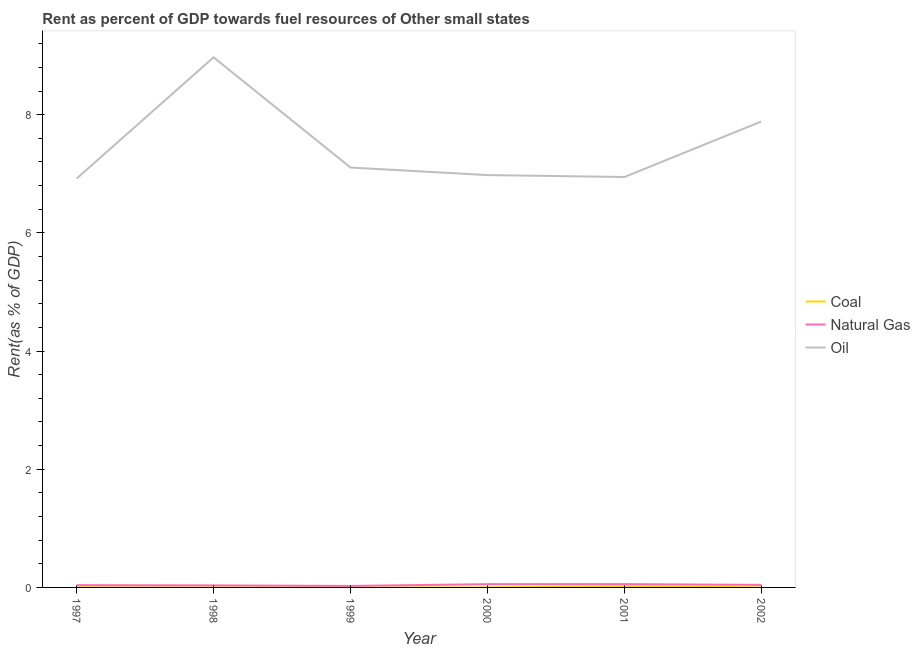How many different coloured lines are there?
Give a very brief answer. 3. Does the line corresponding to rent towards natural gas intersect with the line corresponding to rent towards coal?
Your answer should be compact. No. What is the rent towards oil in 2000?
Your answer should be very brief. 6.98. Across all years, what is the maximum rent towards coal?
Give a very brief answer. 0.02. Across all years, what is the minimum rent towards oil?
Your response must be concise. 6.92. In which year was the rent towards coal maximum?
Give a very brief answer. 2001. In which year was the rent towards natural gas minimum?
Offer a terse response. 1999. What is the total rent towards natural gas in the graph?
Keep it short and to the point. 0.25. What is the difference between the rent towards natural gas in 2000 and that in 2002?
Provide a succinct answer. 0.01. What is the difference between the rent towards natural gas in 1997 and the rent towards coal in 1999?
Ensure brevity in your answer.  0.04. What is the average rent towards oil per year?
Provide a succinct answer. 7.47. In the year 2000, what is the difference between the rent towards coal and rent towards natural gas?
Provide a short and direct response. -0.05. In how many years, is the rent towards oil greater than 3.6 %?
Provide a succinct answer. 6. What is the ratio of the rent towards natural gas in 1997 to that in 2000?
Your response must be concise. 0.7. Is the rent towards natural gas in 1998 less than that in 1999?
Ensure brevity in your answer.  No. What is the difference between the highest and the second highest rent towards natural gas?
Your response must be concise. 0. What is the difference between the highest and the lowest rent towards natural gas?
Your answer should be very brief. 0.03. In how many years, is the rent towards oil greater than the average rent towards oil taken over all years?
Make the answer very short. 2. Is it the case that in every year, the sum of the rent towards coal and rent towards natural gas is greater than the rent towards oil?
Make the answer very short. No. Does the rent towards oil monotonically increase over the years?
Provide a short and direct response. No. Is the rent towards coal strictly greater than the rent towards natural gas over the years?
Ensure brevity in your answer.  No. How many years are there in the graph?
Make the answer very short. 6. Are the values on the major ticks of Y-axis written in scientific E-notation?
Make the answer very short. No. Does the graph contain any zero values?
Make the answer very short. No. Where does the legend appear in the graph?
Your answer should be very brief. Center right. How many legend labels are there?
Give a very brief answer. 3. How are the legend labels stacked?
Give a very brief answer. Vertical. What is the title of the graph?
Your response must be concise. Rent as percent of GDP towards fuel resources of Other small states. What is the label or title of the Y-axis?
Ensure brevity in your answer.  Rent(as % of GDP). What is the Rent(as % of GDP) in Coal in 1997?
Make the answer very short. 0. What is the Rent(as % of GDP) of Natural Gas in 1997?
Make the answer very short. 0.04. What is the Rent(as % of GDP) of Oil in 1997?
Keep it short and to the point. 6.92. What is the Rent(as % of GDP) in Coal in 1998?
Give a very brief answer. 0. What is the Rent(as % of GDP) in Natural Gas in 1998?
Your answer should be compact. 0.03. What is the Rent(as % of GDP) of Oil in 1998?
Keep it short and to the point. 8.97. What is the Rent(as % of GDP) in Coal in 1999?
Provide a short and direct response. 8.31774864799922e-5. What is the Rent(as % of GDP) of Natural Gas in 1999?
Offer a very short reply. 0.03. What is the Rent(as % of GDP) of Oil in 1999?
Your response must be concise. 7.11. What is the Rent(as % of GDP) in Coal in 2000?
Make the answer very short. 0. What is the Rent(as % of GDP) in Natural Gas in 2000?
Give a very brief answer. 0.06. What is the Rent(as % of GDP) of Oil in 2000?
Give a very brief answer. 6.98. What is the Rent(as % of GDP) in Coal in 2001?
Provide a succinct answer. 0.02. What is the Rent(as % of GDP) of Natural Gas in 2001?
Ensure brevity in your answer.  0.06. What is the Rent(as % of GDP) in Oil in 2001?
Make the answer very short. 6.95. What is the Rent(as % of GDP) in Coal in 2002?
Keep it short and to the point. 0. What is the Rent(as % of GDP) of Natural Gas in 2002?
Make the answer very short. 0.04. What is the Rent(as % of GDP) in Oil in 2002?
Make the answer very short. 7.89. Across all years, what is the maximum Rent(as % of GDP) in Coal?
Offer a terse response. 0.02. Across all years, what is the maximum Rent(as % of GDP) in Natural Gas?
Offer a very short reply. 0.06. Across all years, what is the maximum Rent(as % of GDP) in Oil?
Your answer should be very brief. 8.97. Across all years, what is the minimum Rent(as % of GDP) of Coal?
Your answer should be very brief. 8.31774864799922e-5. Across all years, what is the minimum Rent(as % of GDP) of Natural Gas?
Keep it short and to the point. 0.03. Across all years, what is the minimum Rent(as % of GDP) of Oil?
Keep it short and to the point. 6.92. What is the total Rent(as % of GDP) in Coal in the graph?
Give a very brief answer. 0.02. What is the total Rent(as % of GDP) of Natural Gas in the graph?
Offer a terse response. 0.25. What is the total Rent(as % of GDP) in Oil in the graph?
Make the answer very short. 44.8. What is the difference between the Rent(as % of GDP) in Coal in 1997 and that in 1998?
Your response must be concise. 0. What is the difference between the Rent(as % of GDP) of Natural Gas in 1997 and that in 1998?
Ensure brevity in your answer.  0. What is the difference between the Rent(as % of GDP) in Oil in 1997 and that in 1998?
Give a very brief answer. -2.05. What is the difference between the Rent(as % of GDP) in Coal in 1997 and that in 1999?
Offer a very short reply. 0. What is the difference between the Rent(as % of GDP) in Natural Gas in 1997 and that in 1999?
Ensure brevity in your answer.  0.01. What is the difference between the Rent(as % of GDP) of Oil in 1997 and that in 1999?
Keep it short and to the point. -0.19. What is the difference between the Rent(as % of GDP) of Coal in 1997 and that in 2000?
Offer a very short reply. 0. What is the difference between the Rent(as % of GDP) in Natural Gas in 1997 and that in 2000?
Keep it short and to the point. -0.02. What is the difference between the Rent(as % of GDP) of Oil in 1997 and that in 2000?
Your answer should be compact. -0.06. What is the difference between the Rent(as % of GDP) of Coal in 1997 and that in 2001?
Offer a terse response. -0.02. What is the difference between the Rent(as % of GDP) of Natural Gas in 1997 and that in 2001?
Your response must be concise. -0.02. What is the difference between the Rent(as % of GDP) of Oil in 1997 and that in 2001?
Your response must be concise. -0.03. What is the difference between the Rent(as % of GDP) in Coal in 1997 and that in 2002?
Your response must be concise. 0. What is the difference between the Rent(as % of GDP) in Natural Gas in 1997 and that in 2002?
Provide a succinct answer. -0. What is the difference between the Rent(as % of GDP) of Oil in 1997 and that in 2002?
Ensure brevity in your answer.  -0.97. What is the difference between the Rent(as % of GDP) in Coal in 1998 and that in 1999?
Your response must be concise. 0. What is the difference between the Rent(as % of GDP) in Natural Gas in 1998 and that in 1999?
Your response must be concise. 0.01. What is the difference between the Rent(as % of GDP) of Oil in 1998 and that in 1999?
Ensure brevity in your answer.  1.87. What is the difference between the Rent(as % of GDP) of Coal in 1998 and that in 2000?
Provide a succinct answer. 0. What is the difference between the Rent(as % of GDP) of Natural Gas in 1998 and that in 2000?
Your answer should be very brief. -0.02. What is the difference between the Rent(as % of GDP) in Oil in 1998 and that in 2000?
Offer a very short reply. 1.99. What is the difference between the Rent(as % of GDP) of Coal in 1998 and that in 2001?
Your answer should be compact. -0.02. What is the difference between the Rent(as % of GDP) in Natural Gas in 1998 and that in 2001?
Keep it short and to the point. -0.02. What is the difference between the Rent(as % of GDP) of Oil in 1998 and that in 2001?
Give a very brief answer. 2.03. What is the difference between the Rent(as % of GDP) in Coal in 1998 and that in 2002?
Keep it short and to the point. -0. What is the difference between the Rent(as % of GDP) in Natural Gas in 1998 and that in 2002?
Give a very brief answer. -0.01. What is the difference between the Rent(as % of GDP) in Oil in 1998 and that in 2002?
Provide a short and direct response. 1.09. What is the difference between the Rent(as % of GDP) in Coal in 1999 and that in 2000?
Offer a terse response. -0. What is the difference between the Rent(as % of GDP) of Natural Gas in 1999 and that in 2000?
Offer a very short reply. -0.03. What is the difference between the Rent(as % of GDP) of Oil in 1999 and that in 2000?
Make the answer very short. 0.13. What is the difference between the Rent(as % of GDP) in Coal in 1999 and that in 2001?
Offer a very short reply. -0.02. What is the difference between the Rent(as % of GDP) of Natural Gas in 1999 and that in 2001?
Your answer should be very brief. -0.03. What is the difference between the Rent(as % of GDP) of Oil in 1999 and that in 2001?
Keep it short and to the point. 0.16. What is the difference between the Rent(as % of GDP) of Coal in 1999 and that in 2002?
Offer a terse response. -0. What is the difference between the Rent(as % of GDP) of Natural Gas in 1999 and that in 2002?
Your answer should be compact. -0.02. What is the difference between the Rent(as % of GDP) of Oil in 1999 and that in 2002?
Offer a terse response. -0.78. What is the difference between the Rent(as % of GDP) of Coal in 2000 and that in 2001?
Keep it short and to the point. -0.02. What is the difference between the Rent(as % of GDP) in Natural Gas in 2000 and that in 2001?
Your answer should be very brief. -0. What is the difference between the Rent(as % of GDP) of Oil in 2000 and that in 2001?
Offer a terse response. 0.03. What is the difference between the Rent(as % of GDP) of Coal in 2000 and that in 2002?
Make the answer very short. -0. What is the difference between the Rent(as % of GDP) of Natural Gas in 2000 and that in 2002?
Keep it short and to the point. 0.01. What is the difference between the Rent(as % of GDP) of Oil in 2000 and that in 2002?
Your answer should be very brief. -0.91. What is the difference between the Rent(as % of GDP) in Coal in 2001 and that in 2002?
Make the answer very short. 0.02. What is the difference between the Rent(as % of GDP) of Natural Gas in 2001 and that in 2002?
Provide a short and direct response. 0.01. What is the difference between the Rent(as % of GDP) of Oil in 2001 and that in 2002?
Make the answer very short. -0.94. What is the difference between the Rent(as % of GDP) of Coal in 1997 and the Rent(as % of GDP) of Natural Gas in 1998?
Offer a very short reply. -0.03. What is the difference between the Rent(as % of GDP) in Coal in 1997 and the Rent(as % of GDP) in Oil in 1998?
Your answer should be compact. -8.97. What is the difference between the Rent(as % of GDP) in Natural Gas in 1997 and the Rent(as % of GDP) in Oil in 1998?
Give a very brief answer. -8.93. What is the difference between the Rent(as % of GDP) of Coal in 1997 and the Rent(as % of GDP) of Natural Gas in 1999?
Give a very brief answer. -0.02. What is the difference between the Rent(as % of GDP) in Coal in 1997 and the Rent(as % of GDP) in Oil in 1999?
Your answer should be very brief. -7.1. What is the difference between the Rent(as % of GDP) in Natural Gas in 1997 and the Rent(as % of GDP) in Oil in 1999?
Provide a succinct answer. -7.07. What is the difference between the Rent(as % of GDP) in Coal in 1997 and the Rent(as % of GDP) in Natural Gas in 2000?
Your answer should be compact. -0.05. What is the difference between the Rent(as % of GDP) of Coal in 1997 and the Rent(as % of GDP) of Oil in 2000?
Offer a terse response. -6.98. What is the difference between the Rent(as % of GDP) of Natural Gas in 1997 and the Rent(as % of GDP) of Oil in 2000?
Keep it short and to the point. -6.94. What is the difference between the Rent(as % of GDP) of Coal in 1997 and the Rent(as % of GDP) of Natural Gas in 2001?
Provide a short and direct response. -0.05. What is the difference between the Rent(as % of GDP) of Coal in 1997 and the Rent(as % of GDP) of Oil in 2001?
Keep it short and to the point. -6.94. What is the difference between the Rent(as % of GDP) of Natural Gas in 1997 and the Rent(as % of GDP) of Oil in 2001?
Offer a very short reply. -6.91. What is the difference between the Rent(as % of GDP) in Coal in 1997 and the Rent(as % of GDP) in Natural Gas in 2002?
Your answer should be very brief. -0.04. What is the difference between the Rent(as % of GDP) of Coal in 1997 and the Rent(as % of GDP) of Oil in 2002?
Your answer should be very brief. -7.88. What is the difference between the Rent(as % of GDP) in Natural Gas in 1997 and the Rent(as % of GDP) in Oil in 2002?
Offer a very short reply. -7.85. What is the difference between the Rent(as % of GDP) in Coal in 1998 and the Rent(as % of GDP) in Natural Gas in 1999?
Ensure brevity in your answer.  -0.02. What is the difference between the Rent(as % of GDP) of Coal in 1998 and the Rent(as % of GDP) of Oil in 1999?
Ensure brevity in your answer.  -7.11. What is the difference between the Rent(as % of GDP) of Natural Gas in 1998 and the Rent(as % of GDP) of Oil in 1999?
Your answer should be compact. -7.07. What is the difference between the Rent(as % of GDP) of Coal in 1998 and the Rent(as % of GDP) of Natural Gas in 2000?
Provide a succinct answer. -0.05. What is the difference between the Rent(as % of GDP) in Coal in 1998 and the Rent(as % of GDP) in Oil in 2000?
Ensure brevity in your answer.  -6.98. What is the difference between the Rent(as % of GDP) in Natural Gas in 1998 and the Rent(as % of GDP) in Oil in 2000?
Your answer should be very brief. -6.94. What is the difference between the Rent(as % of GDP) of Coal in 1998 and the Rent(as % of GDP) of Natural Gas in 2001?
Provide a succinct answer. -0.06. What is the difference between the Rent(as % of GDP) of Coal in 1998 and the Rent(as % of GDP) of Oil in 2001?
Your answer should be compact. -6.94. What is the difference between the Rent(as % of GDP) in Natural Gas in 1998 and the Rent(as % of GDP) in Oil in 2001?
Your response must be concise. -6.91. What is the difference between the Rent(as % of GDP) of Coal in 1998 and the Rent(as % of GDP) of Natural Gas in 2002?
Give a very brief answer. -0.04. What is the difference between the Rent(as % of GDP) of Coal in 1998 and the Rent(as % of GDP) of Oil in 2002?
Your answer should be compact. -7.88. What is the difference between the Rent(as % of GDP) of Natural Gas in 1998 and the Rent(as % of GDP) of Oil in 2002?
Your answer should be very brief. -7.85. What is the difference between the Rent(as % of GDP) in Coal in 1999 and the Rent(as % of GDP) in Natural Gas in 2000?
Make the answer very short. -0.05. What is the difference between the Rent(as % of GDP) in Coal in 1999 and the Rent(as % of GDP) in Oil in 2000?
Make the answer very short. -6.98. What is the difference between the Rent(as % of GDP) in Natural Gas in 1999 and the Rent(as % of GDP) in Oil in 2000?
Ensure brevity in your answer.  -6.95. What is the difference between the Rent(as % of GDP) of Coal in 1999 and the Rent(as % of GDP) of Natural Gas in 2001?
Ensure brevity in your answer.  -0.06. What is the difference between the Rent(as % of GDP) of Coal in 1999 and the Rent(as % of GDP) of Oil in 2001?
Offer a terse response. -6.95. What is the difference between the Rent(as % of GDP) in Natural Gas in 1999 and the Rent(as % of GDP) in Oil in 2001?
Your answer should be very brief. -6.92. What is the difference between the Rent(as % of GDP) of Coal in 1999 and the Rent(as % of GDP) of Natural Gas in 2002?
Make the answer very short. -0.04. What is the difference between the Rent(as % of GDP) in Coal in 1999 and the Rent(as % of GDP) in Oil in 2002?
Make the answer very short. -7.88. What is the difference between the Rent(as % of GDP) of Natural Gas in 1999 and the Rent(as % of GDP) of Oil in 2002?
Make the answer very short. -7.86. What is the difference between the Rent(as % of GDP) of Coal in 2000 and the Rent(as % of GDP) of Natural Gas in 2001?
Provide a succinct answer. -0.06. What is the difference between the Rent(as % of GDP) in Coal in 2000 and the Rent(as % of GDP) in Oil in 2001?
Keep it short and to the point. -6.95. What is the difference between the Rent(as % of GDP) of Natural Gas in 2000 and the Rent(as % of GDP) of Oil in 2001?
Your answer should be very brief. -6.89. What is the difference between the Rent(as % of GDP) of Coal in 2000 and the Rent(as % of GDP) of Natural Gas in 2002?
Make the answer very short. -0.04. What is the difference between the Rent(as % of GDP) of Coal in 2000 and the Rent(as % of GDP) of Oil in 2002?
Offer a very short reply. -7.88. What is the difference between the Rent(as % of GDP) of Natural Gas in 2000 and the Rent(as % of GDP) of Oil in 2002?
Provide a short and direct response. -7.83. What is the difference between the Rent(as % of GDP) in Coal in 2001 and the Rent(as % of GDP) in Natural Gas in 2002?
Make the answer very short. -0.02. What is the difference between the Rent(as % of GDP) of Coal in 2001 and the Rent(as % of GDP) of Oil in 2002?
Provide a short and direct response. -7.87. What is the difference between the Rent(as % of GDP) of Natural Gas in 2001 and the Rent(as % of GDP) of Oil in 2002?
Your answer should be very brief. -7.83. What is the average Rent(as % of GDP) in Coal per year?
Your answer should be compact. 0. What is the average Rent(as % of GDP) in Natural Gas per year?
Offer a very short reply. 0.04. What is the average Rent(as % of GDP) of Oil per year?
Provide a succinct answer. 7.47. In the year 1997, what is the difference between the Rent(as % of GDP) in Coal and Rent(as % of GDP) in Natural Gas?
Ensure brevity in your answer.  -0.04. In the year 1997, what is the difference between the Rent(as % of GDP) in Coal and Rent(as % of GDP) in Oil?
Offer a very short reply. -6.92. In the year 1997, what is the difference between the Rent(as % of GDP) of Natural Gas and Rent(as % of GDP) of Oil?
Offer a terse response. -6.88. In the year 1998, what is the difference between the Rent(as % of GDP) in Coal and Rent(as % of GDP) in Natural Gas?
Your answer should be compact. -0.03. In the year 1998, what is the difference between the Rent(as % of GDP) in Coal and Rent(as % of GDP) in Oil?
Your answer should be compact. -8.97. In the year 1998, what is the difference between the Rent(as % of GDP) of Natural Gas and Rent(as % of GDP) of Oil?
Provide a short and direct response. -8.94. In the year 1999, what is the difference between the Rent(as % of GDP) of Coal and Rent(as % of GDP) of Natural Gas?
Offer a very short reply. -0.03. In the year 1999, what is the difference between the Rent(as % of GDP) of Coal and Rent(as % of GDP) of Oil?
Your response must be concise. -7.11. In the year 1999, what is the difference between the Rent(as % of GDP) in Natural Gas and Rent(as % of GDP) in Oil?
Ensure brevity in your answer.  -7.08. In the year 2000, what is the difference between the Rent(as % of GDP) in Coal and Rent(as % of GDP) in Natural Gas?
Make the answer very short. -0.05. In the year 2000, what is the difference between the Rent(as % of GDP) in Coal and Rent(as % of GDP) in Oil?
Your answer should be compact. -6.98. In the year 2000, what is the difference between the Rent(as % of GDP) in Natural Gas and Rent(as % of GDP) in Oil?
Your answer should be very brief. -6.92. In the year 2001, what is the difference between the Rent(as % of GDP) of Coal and Rent(as % of GDP) of Natural Gas?
Your answer should be very brief. -0.04. In the year 2001, what is the difference between the Rent(as % of GDP) of Coal and Rent(as % of GDP) of Oil?
Ensure brevity in your answer.  -6.93. In the year 2001, what is the difference between the Rent(as % of GDP) of Natural Gas and Rent(as % of GDP) of Oil?
Give a very brief answer. -6.89. In the year 2002, what is the difference between the Rent(as % of GDP) in Coal and Rent(as % of GDP) in Natural Gas?
Your response must be concise. -0.04. In the year 2002, what is the difference between the Rent(as % of GDP) of Coal and Rent(as % of GDP) of Oil?
Provide a succinct answer. -7.88. In the year 2002, what is the difference between the Rent(as % of GDP) in Natural Gas and Rent(as % of GDP) in Oil?
Your answer should be very brief. -7.84. What is the ratio of the Rent(as % of GDP) of Coal in 1997 to that in 1998?
Your response must be concise. 2.47. What is the ratio of the Rent(as % of GDP) in Natural Gas in 1997 to that in 1998?
Keep it short and to the point. 1.11. What is the ratio of the Rent(as % of GDP) of Oil in 1997 to that in 1998?
Make the answer very short. 0.77. What is the ratio of the Rent(as % of GDP) in Coal in 1997 to that in 1999?
Your response must be concise. 16.54. What is the ratio of the Rent(as % of GDP) in Natural Gas in 1997 to that in 1999?
Your answer should be very brief. 1.51. What is the ratio of the Rent(as % of GDP) in Oil in 1997 to that in 1999?
Provide a short and direct response. 0.97. What is the ratio of the Rent(as % of GDP) in Coal in 1997 to that in 2000?
Give a very brief answer. 3.89. What is the ratio of the Rent(as % of GDP) of Natural Gas in 1997 to that in 2000?
Make the answer very short. 0.7. What is the ratio of the Rent(as % of GDP) in Coal in 1997 to that in 2001?
Ensure brevity in your answer.  0.07. What is the ratio of the Rent(as % of GDP) in Natural Gas in 1997 to that in 2001?
Offer a terse response. 0.68. What is the ratio of the Rent(as % of GDP) in Coal in 1997 to that in 2002?
Provide a succinct answer. 1.06. What is the ratio of the Rent(as % of GDP) of Natural Gas in 1997 to that in 2002?
Ensure brevity in your answer.  0.9. What is the ratio of the Rent(as % of GDP) in Oil in 1997 to that in 2002?
Ensure brevity in your answer.  0.88. What is the ratio of the Rent(as % of GDP) in Coal in 1998 to that in 1999?
Your response must be concise. 6.69. What is the ratio of the Rent(as % of GDP) of Natural Gas in 1998 to that in 1999?
Offer a terse response. 1.36. What is the ratio of the Rent(as % of GDP) in Oil in 1998 to that in 1999?
Provide a short and direct response. 1.26. What is the ratio of the Rent(as % of GDP) in Coal in 1998 to that in 2000?
Offer a terse response. 1.57. What is the ratio of the Rent(as % of GDP) in Natural Gas in 1998 to that in 2000?
Provide a short and direct response. 0.63. What is the ratio of the Rent(as % of GDP) in Oil in 1998 to that in 2000?
Keep it short and to the point. 1.29. What is the ratio of the Rent(as % of GDP) in Coal in 1998 to that in 2001?
Your answer should be compact. 0.03. What is the ratio of the Rent(as % of GDP) of Natural Gas in 1998 to that in 2001?
Your response must be concise. 0.61. What is the ratio of the Rent(as % of GDP) in Oil in 1998 to that in 2001?
Your response must be concise. 1.29. What is the ratio of the Rent(as % of GDP) in Coal in 1998 to that in 2002?
Make the answer very short. 0.43. What is the ratio of the Rent(as % of GDP) in Natural Gas in 1998 to that in 2002?
Provide a succinct answer. 0.81. What is the ratio of the Rent(as % of GDP) in Oil in 1998 to that in 2002?
Make the answer very short. 1.14. What is the ratio of the Rent(as % of GDP) in Coal in 1999 to that in 2000?
Provide a short and direct response. 0.24. What is the ratio of the Rent(as % of GDP) in Natural Gas in 1999 to that in 2000?
Provide a succinct answer. 0.46. What is the ratio of the Rent(as % of GDP) of Oil in 1999 to that in 2000?
Provide a short and direct response. 1.02. What is the ratio of the Rent(as % of GDP) of Coal in 1999 to that in 2001?
Your answer should be very brief. 0. What is the ratio of the Rent(as % of GDP) of Natural Gas in 1999 to that in 2001?
Provide a short and direct response. 0.45. What is the ratio of the Rent(as % of GDP) of Oil in 1999 to that in 2001?
Keep it short and to the point. 1.02. What is the ratio of the Rent(as % of GDP) in Coal in 1999 to that in 2002?
Your answer should be very brief. 0.06. What is the ratio of the Rent(as % of GDP) of Natural Gas in 1999 to that in 2002?
Offer a very short reply. 0.59. What is the ratio of the Rent(as % of GDP) of Oil in 1999 to that in 2002?
Provide a succinct answer. 0.9. What is the ratio of the Rent(as % of GDP) in Coal in 2000 to that in 2001?
Give a very brief answer. 0.02. What is the ratio of the Rent(as % of GDP) in Natural Gas in 2000 to that in 2001?
Make the answer very short. 0.98. What is the ratio of the Rent(as % of GDP) of Oil in 2000 to that in 2001?
Keep it short and to the point. 1. What is the ratio of the Rent(as % of GDP) in Coal in 2000 to that in 2002?
Provide a short and direct response. 0.27. What is the ratio of the Rent(as % of GDP) of Natural Gas in 2000 to that in 2002?
Offer a terse response. 1.29. What is the ratio of the Rent(as % of GDP) in Oil in 2000 to that in 2002?
Your answer should be compact. 0.89. What is the ratio of the Rent(as % of GDP) in Coal in 2001 to that in 2002?
Offer a very short reply. 14.64. What is the ratio of the Rent(as % of GDP) of Natural Gas in 2001 to that in 2002?
Your response must be concise. 1.31. What is the ratio of the Rent(as % of GDP) of Oil in 2001 to that in 2002?
Your answer should be very brief. 0.88. What is the difference between the highest and the second highest Rent(as % of GDP) in Coal?
Your answer should be very brief. 0.02. What is the difference between the highest and the second highest Rent(as % of GDP) in Natural Gas?
Your answer should be compact. 0. What is the difference between the highest and the second highest Rent(as % of GDP) in Oil?
Ensure brevity in your answer.  1.09. What is the difference between the highest and the lowest Rent(as % of GDP) in Coal?
Make the answer very short. 0.02. What is the difference between the highest and the lowest Rent(as % of GDP) in Natural Gas?
Keep it short and to the point. 0.03. What is the difference between the highest and the lowest Rent(as % of GDP) in Oil?
Provide a short and direct response. 2.05. 